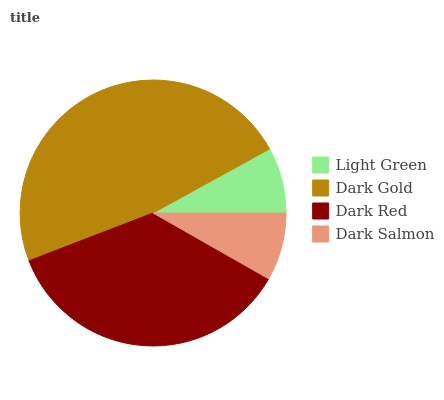Is Light Green the minimum?
Answer yes or no. Yes. Is Dark Gold the maximum?
Answer yes or no. Yes. Is Dark Red the minimum?
Answer yes or no. No. Is Dark Red the maximum?
Answer yes or no. No. Is Dark Gold greater than Dark Red?
Answer yes or no. Yes. Is Dark Red less than Dark Gold?
Answer yes or no. Yes. Is Dark Red greater than Dark Gold?
Answer yes or no. No. Is Dark Gold less than Dark Red?
Answer yes or no. No. Is Dark Red the high median?
Answer yes or no. Yes. Is Dark Salmon the low median?
Answer yes or no. Yes. Is Light Green the high median?
Answer yes or no. No. Is Dark Red the low median?
Answer yes or no. No. 